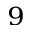Convert formula to latex. <formula><loc_0><loc_0><loc_500><loc_500>^ { 9 }</formula> 